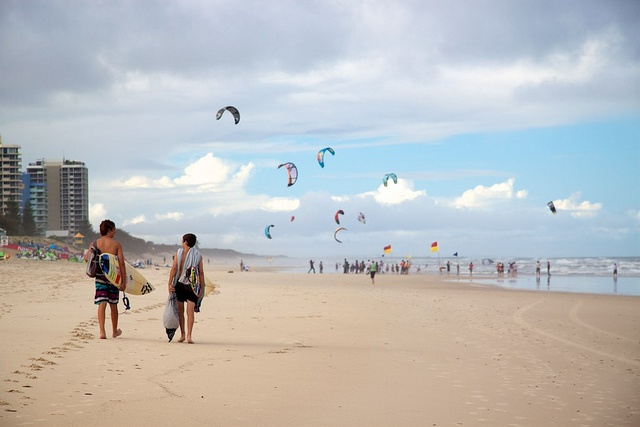Describe the objects in this image and their specific colors. I can see people in darkgray, black, maroon, and brown tones, people in darkgray, black, brown, and maroon tones, people in darkgray and gray tones, surfboard in darkgray, tan, gray, and black tones, and kite in darkgray, lavender, and gray tones in this image. 